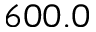Convert formula to latex. <formula><loc_0><loc_0><loc_500><loc_500>6 0 0 . 0</formula> 